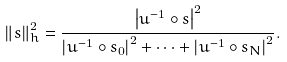<formula> <loc_0><loc_0><loc_500><loc_500>\left \| s \right \| _ { h } ^ { 2 } = \frac { \left | u ^ { - 1 } \circ s \right | ^ { 2 } } { \left | u ^ { - 1 } \circ s _ { 0 } \right | ^ { 2 } + \dots + \left | u ^ { - 1 } \circ s _ { N } \right | ^ { 2 } } .</formula> 